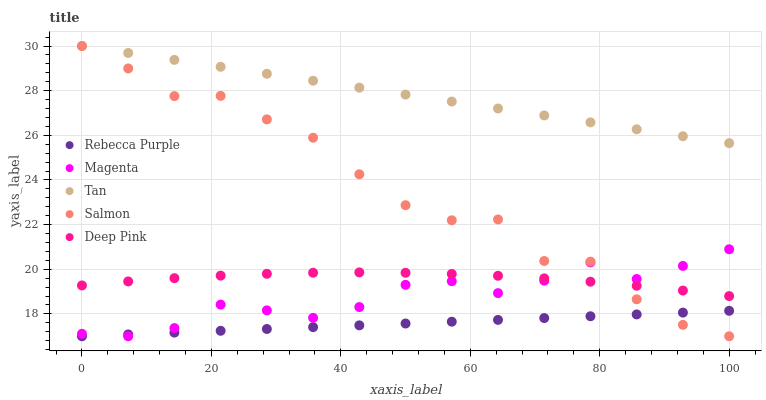Does Rebecca Purple have the minimum area under the curve?
Answer yes or no. Yes. Does Tan have the maximum area under the curve?
Answer yes or no. Yes. Does Magenta have the minimum area under the curve?
Answer yes or no. No. Does Magenta have the maximum area under the curve?
Answer yes or no. No. Is Rebecca Purple the smoothest?
Answer yes or no. Yes. Is Salmon the roughest?
Answer yes or no. Yes. Is Magenta the smoothest?
Answer yes or no. No. Is Magenta the roughest?
Answer yes or no. No. Does Salmon have the lowest value?
Answer yes or no. Yes. Does Deep Pink have the lowest value?
Answer yes or no. No. Does Tan have the highest value?
Answer yes or no. Yes. Does Magenta have the highest value?
Answer yes or no. No. Is Rebecca Purple less than Deep Pink?
Answer yes or no. Yes. Is Tan greater than Deep Pink?
Answer yes or no. Yes. Does Tan intersect Salmon?
Answer yes or no. Yes. Is Tan less than Salmon?
Answer yes or no. No. Is Tan greater than Salmon?
Answer yes or no. No. Does Rebecca Purple intersect Deep Pink?
Answer yes or no. No. 